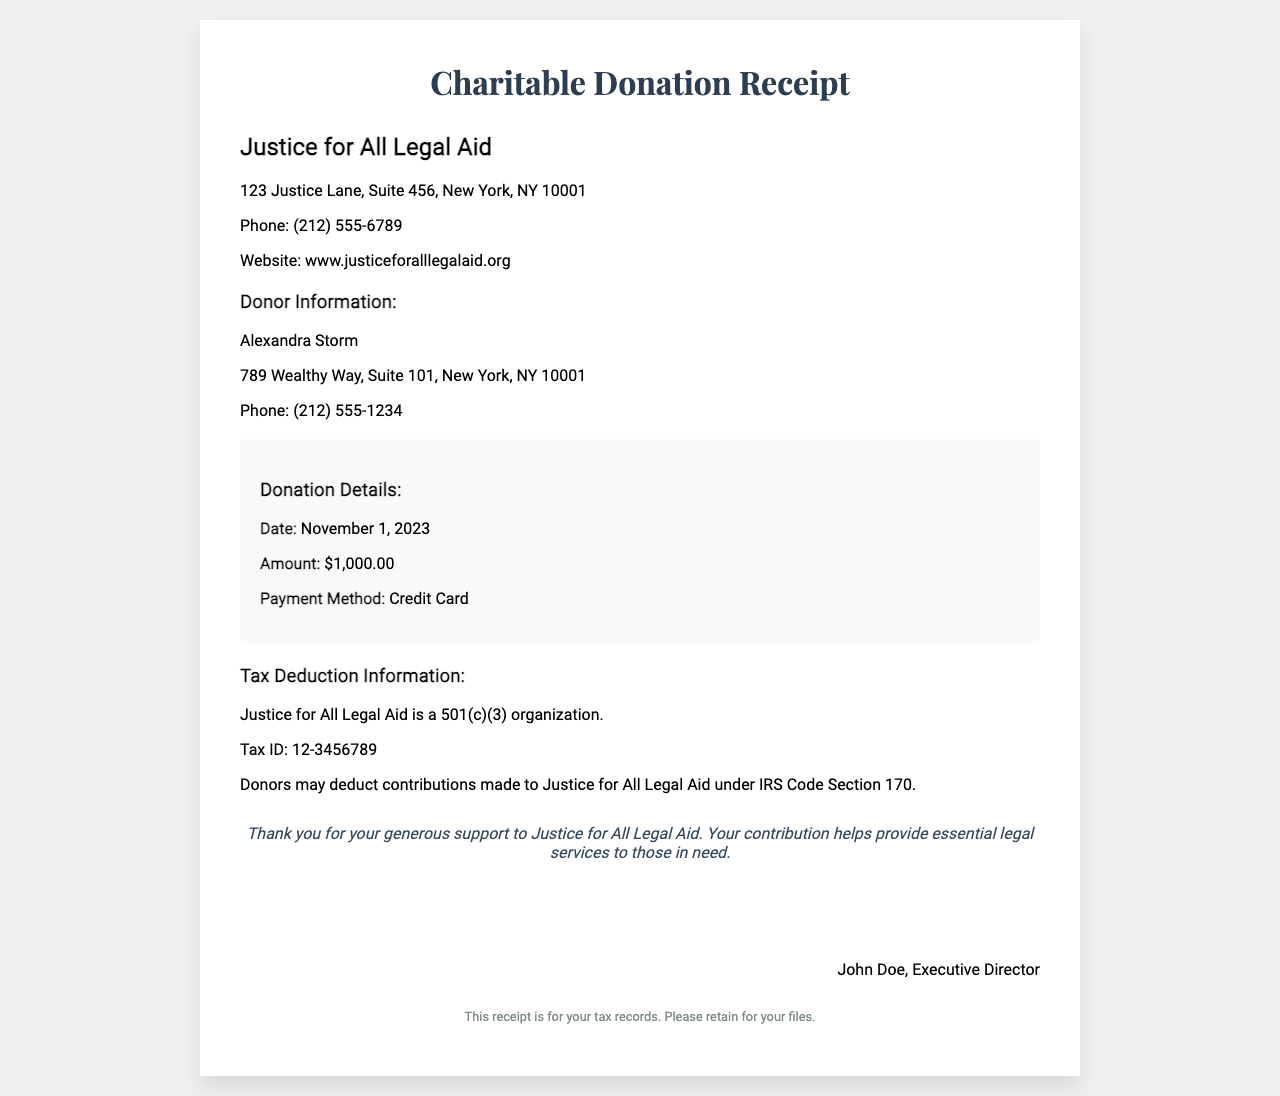What is the name of the organization? The organization name is clearly stated at the top of the receipt under the organization information section.
Answer: Justice for All Legal Aid What is the donation amount? The donation amount is specified in the donation details section of the receipt.
Answer: $1,000.00 What is the tax ID of the organization? The tax ID is listed under the tax deduction information section and is an important detail for tax purposes.
Answer: 12-3456789 When was the donation made? The date of the donation is mentioned in the donation details section.
Answer: November 1, 2023 Who is the donor? The donor's name is prominently displayed under the donor information section of the receipt.
Answer: Alexandra Storm What is the payment method used for the donation? The payment method is listed in the donation details section, which details how the donation was made.
Answer: Credit Card What type of organization is Justice for All Legal Aid? This information is found in the tax deduction section, indicating the organization's qualifying status.
Answer: 501(c)(3) Who signed the receipt? The signature section of the receipt identifies the person who signed it, which is relevant for validation.
Answer: John Doe, Executive Director What is the purpose of the receipt? The footer section specifies the purpose of the receipt in terms of tax record keeping.
Answer: For your tax records 